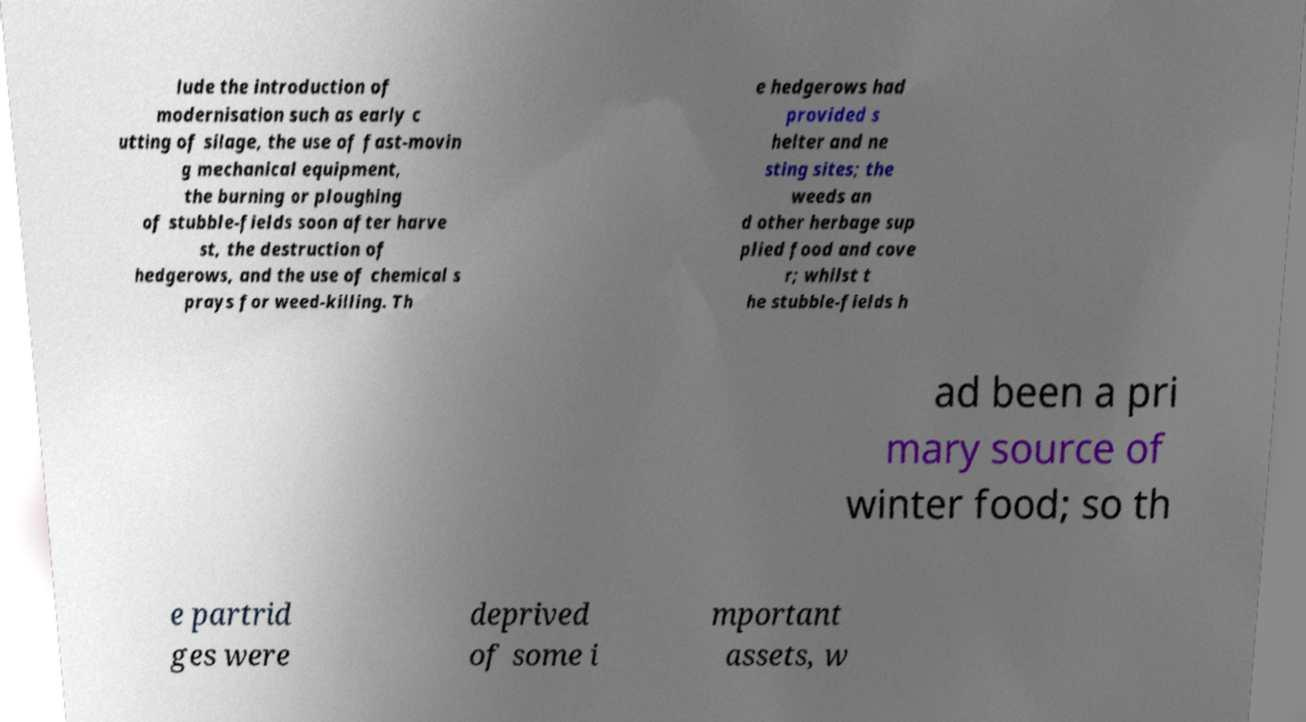Can you read and provide the text displayed in the image?This photo seems to have some interesting text. Can you extract and type it out for me? lude the introduction of modernisation such as early c utting of silage, the use of fast-movin g mechanical equipment, the burning or ploughing of stubble-fields soon after harve st, the destruction of hedgerows, and the use of chemical s prays for weed-killing. Th e hedgerows had provided s helter and ne sting sites; the weeds an d other herbage sup plied food and cove r; whilst t he stubble-fields h ad been a pri mary source of winter food; so th e partrid ges were deprived of some i mportant assets, w 